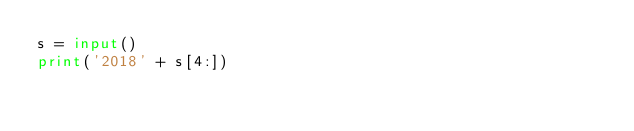<code> <loc_0><loc_0><loc_500><loc_500><_Python_>s = input()
print('2018' + s[4:])</code> 